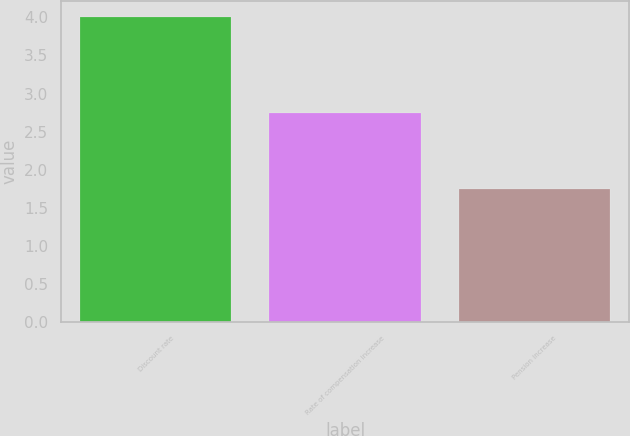<chart> <loc_0><loc_0><loc_500><loc_500><bar_chart><fcel>Discount rate<fcel>Rate of compensation increase<fcel>Pension increase<nl><fcel>4.01<fcel>2.75<fcel>1.75<nl></chart> 